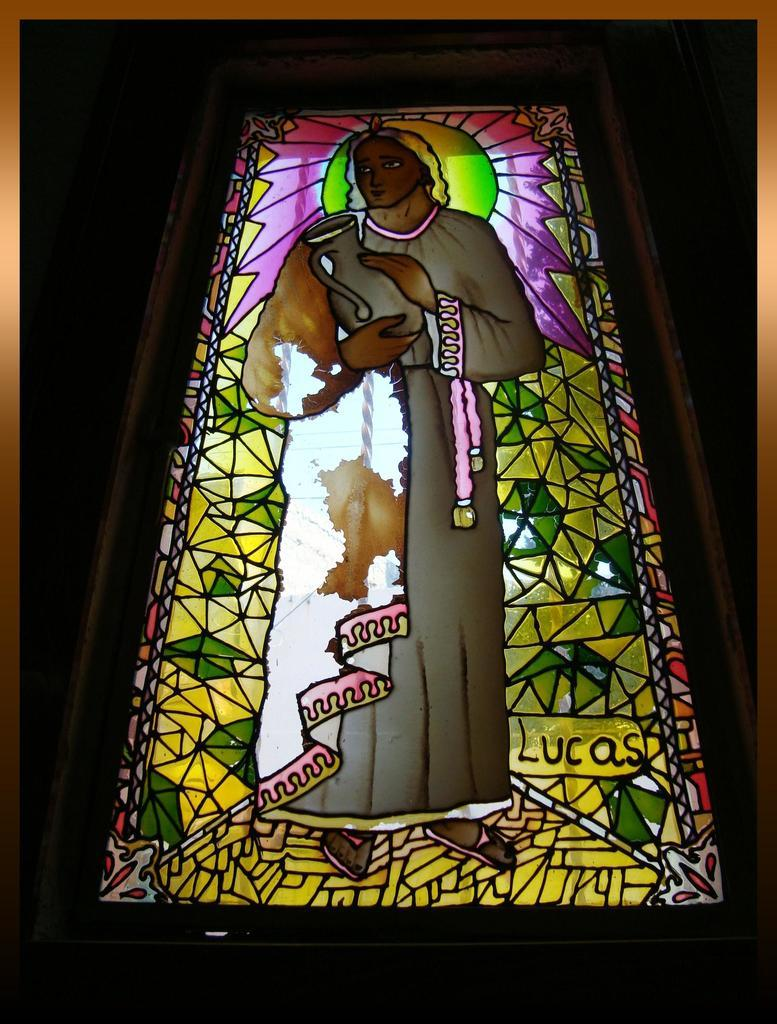What is the main object in the center of the image? There is a glass frame in the center of the image. What is happening with the glass frame? A person is standing on the glass frame. What is the person holding in the image? The person is holding an object. What type of songs can be heard coming from the representative in the image? There is no representative or songs present in the image; it features a person standing on a glass frame and holding an object. 